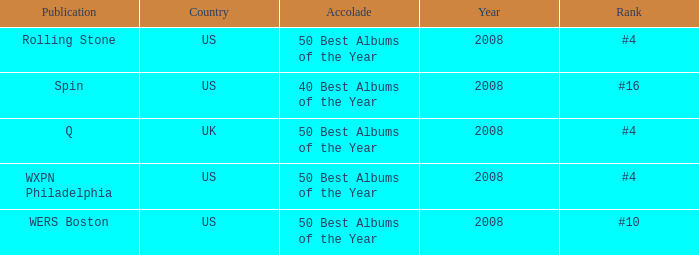Which year's rank was #4 when the country was the US? 2008, 2008. 